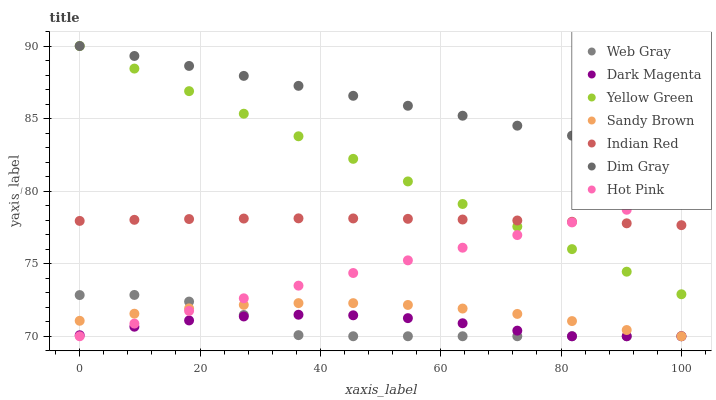Does Web Gray have the minimum area under the curve?
Answer yes or no. Yes. Does Dim Gray have the maximum area under the curve?
Answer yes or no. Yes. Does Dark Magenta have the minimum area under the curve?
Answer yes or no. No. Does Dark Magenta have the maximum area under the curve?
Answer yes or no. No. Is Yellow Green the smoothest?
Answer yes or no. Yes. Is Web Gray the roughest?
Answer yes or no. Yes. Is Dark Magenta the smoothest?
Answer yes or no. No. Is Dark Magenta the roughest?
Answer yes or no. No. Does Dark Magenta have the lowest value?
Answer yes or no. Yes. Does Indian Red have the lowest value?
Answer yes or no. No. Does Yellow Green have the highest value?
Answer yes or no. Yes. Does Hot Pink have the highest value?
Answer yes or no. No. Is Sandy Brown less than Yellow Green?
Answer yes or no. Yes. Is Indian Red greater than Dark Magenta?
Answer yes or no. Yes. Does Web Gray intersect Hot Pink?
Answer yes or no. Yes. Is Web Gray less than Hot Pink?
Answer yes or no. No. Is Web Gray greater than Hot Pink?
Answer yes or no. No. Does Sandy Brown intersect Yellow Green?
Answer yes or no. No. 